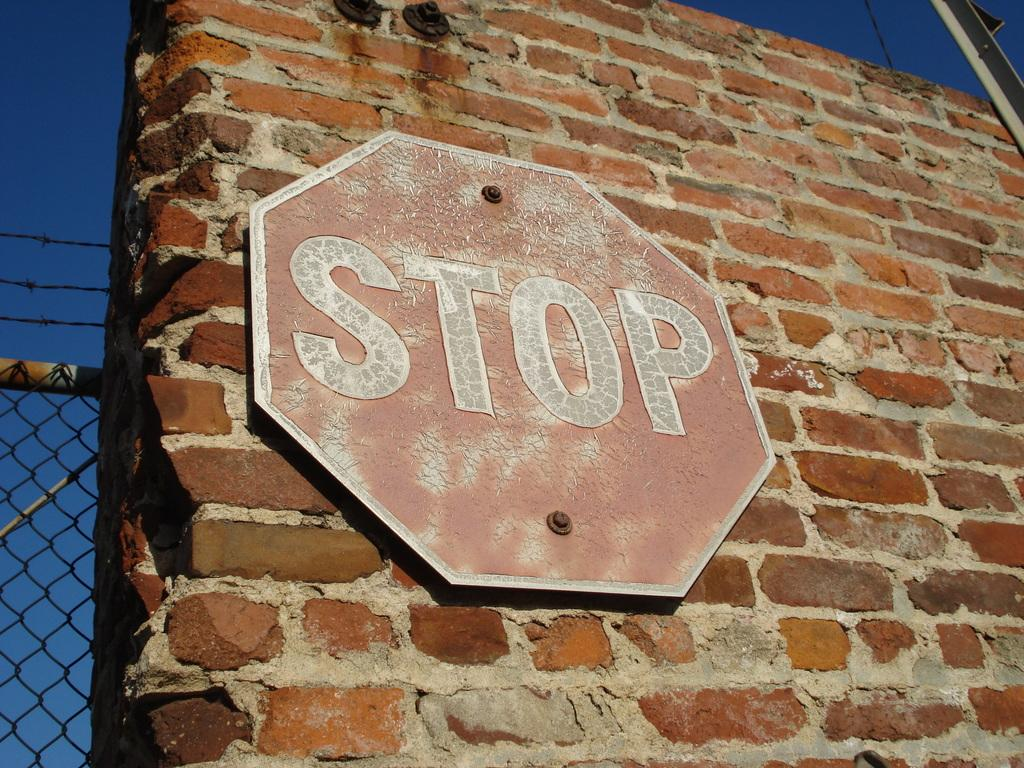<image>
Present a compact description of the photo's key features. A faded red sign posted directly on a brick wall says "stop". 